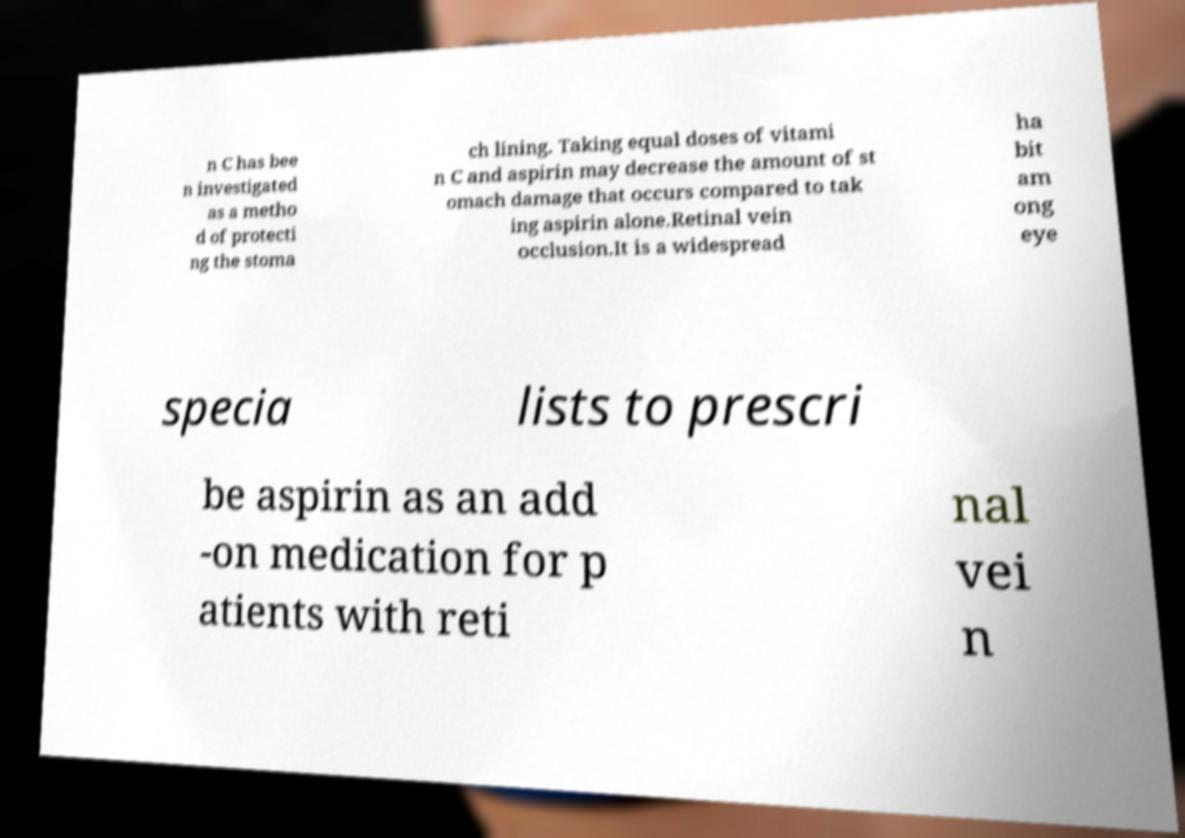For documentation purposes, I need the text within this image transcribed. Could you provide that? n C has bee n investigated as a metho d of protecti ng the stoma ch lining. Taking equal doses of vitami n C and aspirin may decrease the amount of st omach damage that occurs compared to tak ing aspirin alone.Retinal vein occlusion.It is a widespread ha bit am ong eye specia lists to prescri be aspirin as an add -on medication for p atients with reti nal vei n 